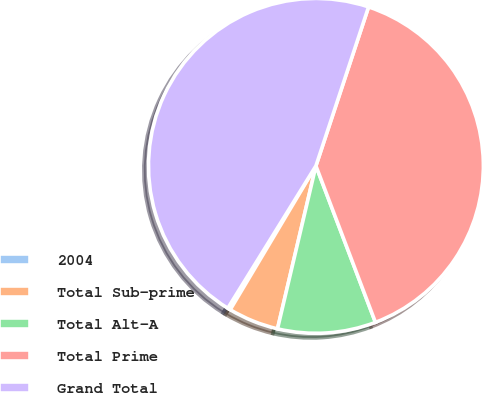Convert chart. <chart><loc_0><loc_0><loc_500><loc_500><pie_chart><fcel>2004<fcel>Total Sub-prime<fcel>Total Alt-A<fcel>Total Prime<fcel>Grand Total<nl><fcel>0.27%<fcel>4.87%<fcel>9.47%<fcel>39.13%<fcel>46.27%<nl></chart> 